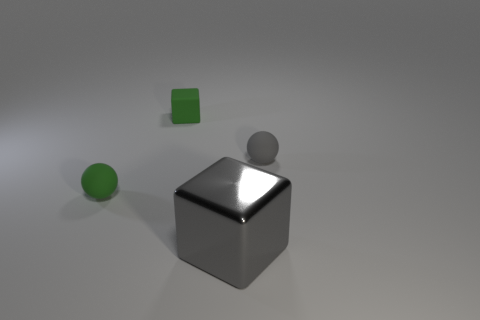Subtract all gray cubes. How many cubes are left? 1 Subtract 2 blocks. How many blocks are left? 0 Add 3 tiny gray rubber balls. How many objects exist? 7 Subtract all small green rubber spheres. Subtract all tiny gray rubber balls. How many objects are left? 2 Add 3 matte balls. How many matte balls are left? 5 Add 2 green blocks. How many green blocks exist? 3 Subtract 0 yellow cylinders. How many objects are left? 4 Subtract all cyan spheres. Subtract all gray blocks. How many spheres are left? 2 Subtract all red blocks. How many red spheres are left? 0 